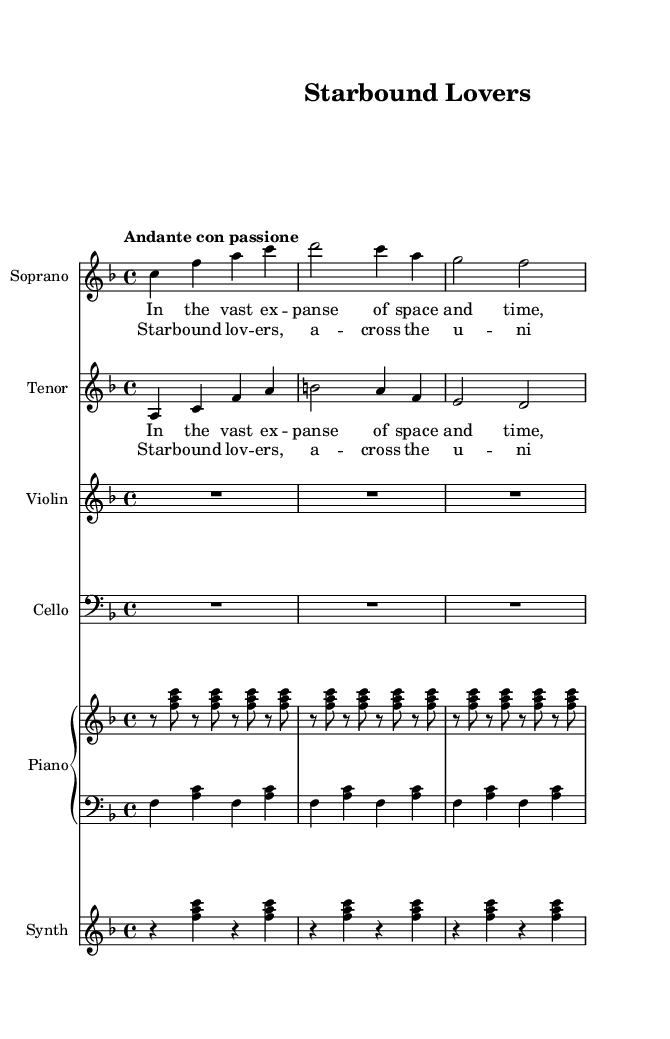What is the key signature of this music? The key signature of this music is F major, which has one flat (B flat). This can be identified at the beginning of the staff where the key signature is indicated.
Answer: F major What is the time signature of this music? The time signature is 4/4, which means there are four beats in each measure and the quarter note gets one beat. This is indicated at the beginning of the score.
Answer: 4/4 What is the tempo marking for this music? The tempo is marked as "Andante con passione," which indicates a moderately slow tempo with passion. This notation is found above the staff in the tempo indication.
Answer: Andante con passione How many staves are used in the score? There are a total of six staves used in the score: one for soprano, one for tenor, one for violin, one for cello, one for piano (which is divided into two parts), and one for synthesizer. This can be counted by looking at the different instrument names labeled on each staff.
Answer: Six What is the main theme of the lyrics in the chorus? The main theme of the lyrics in the chorus is about love and connection across the universe, emphasizing the transcendent nature of their bond. This can be inferred from the lyrics of the chorus provided in the music sheet.
Answer: Love across the universe How many measures are there in the soprano part provided? There are four measures in the soprano part, which can be counted by looking at the individual segments of music between the barlines.
Answer: Four 